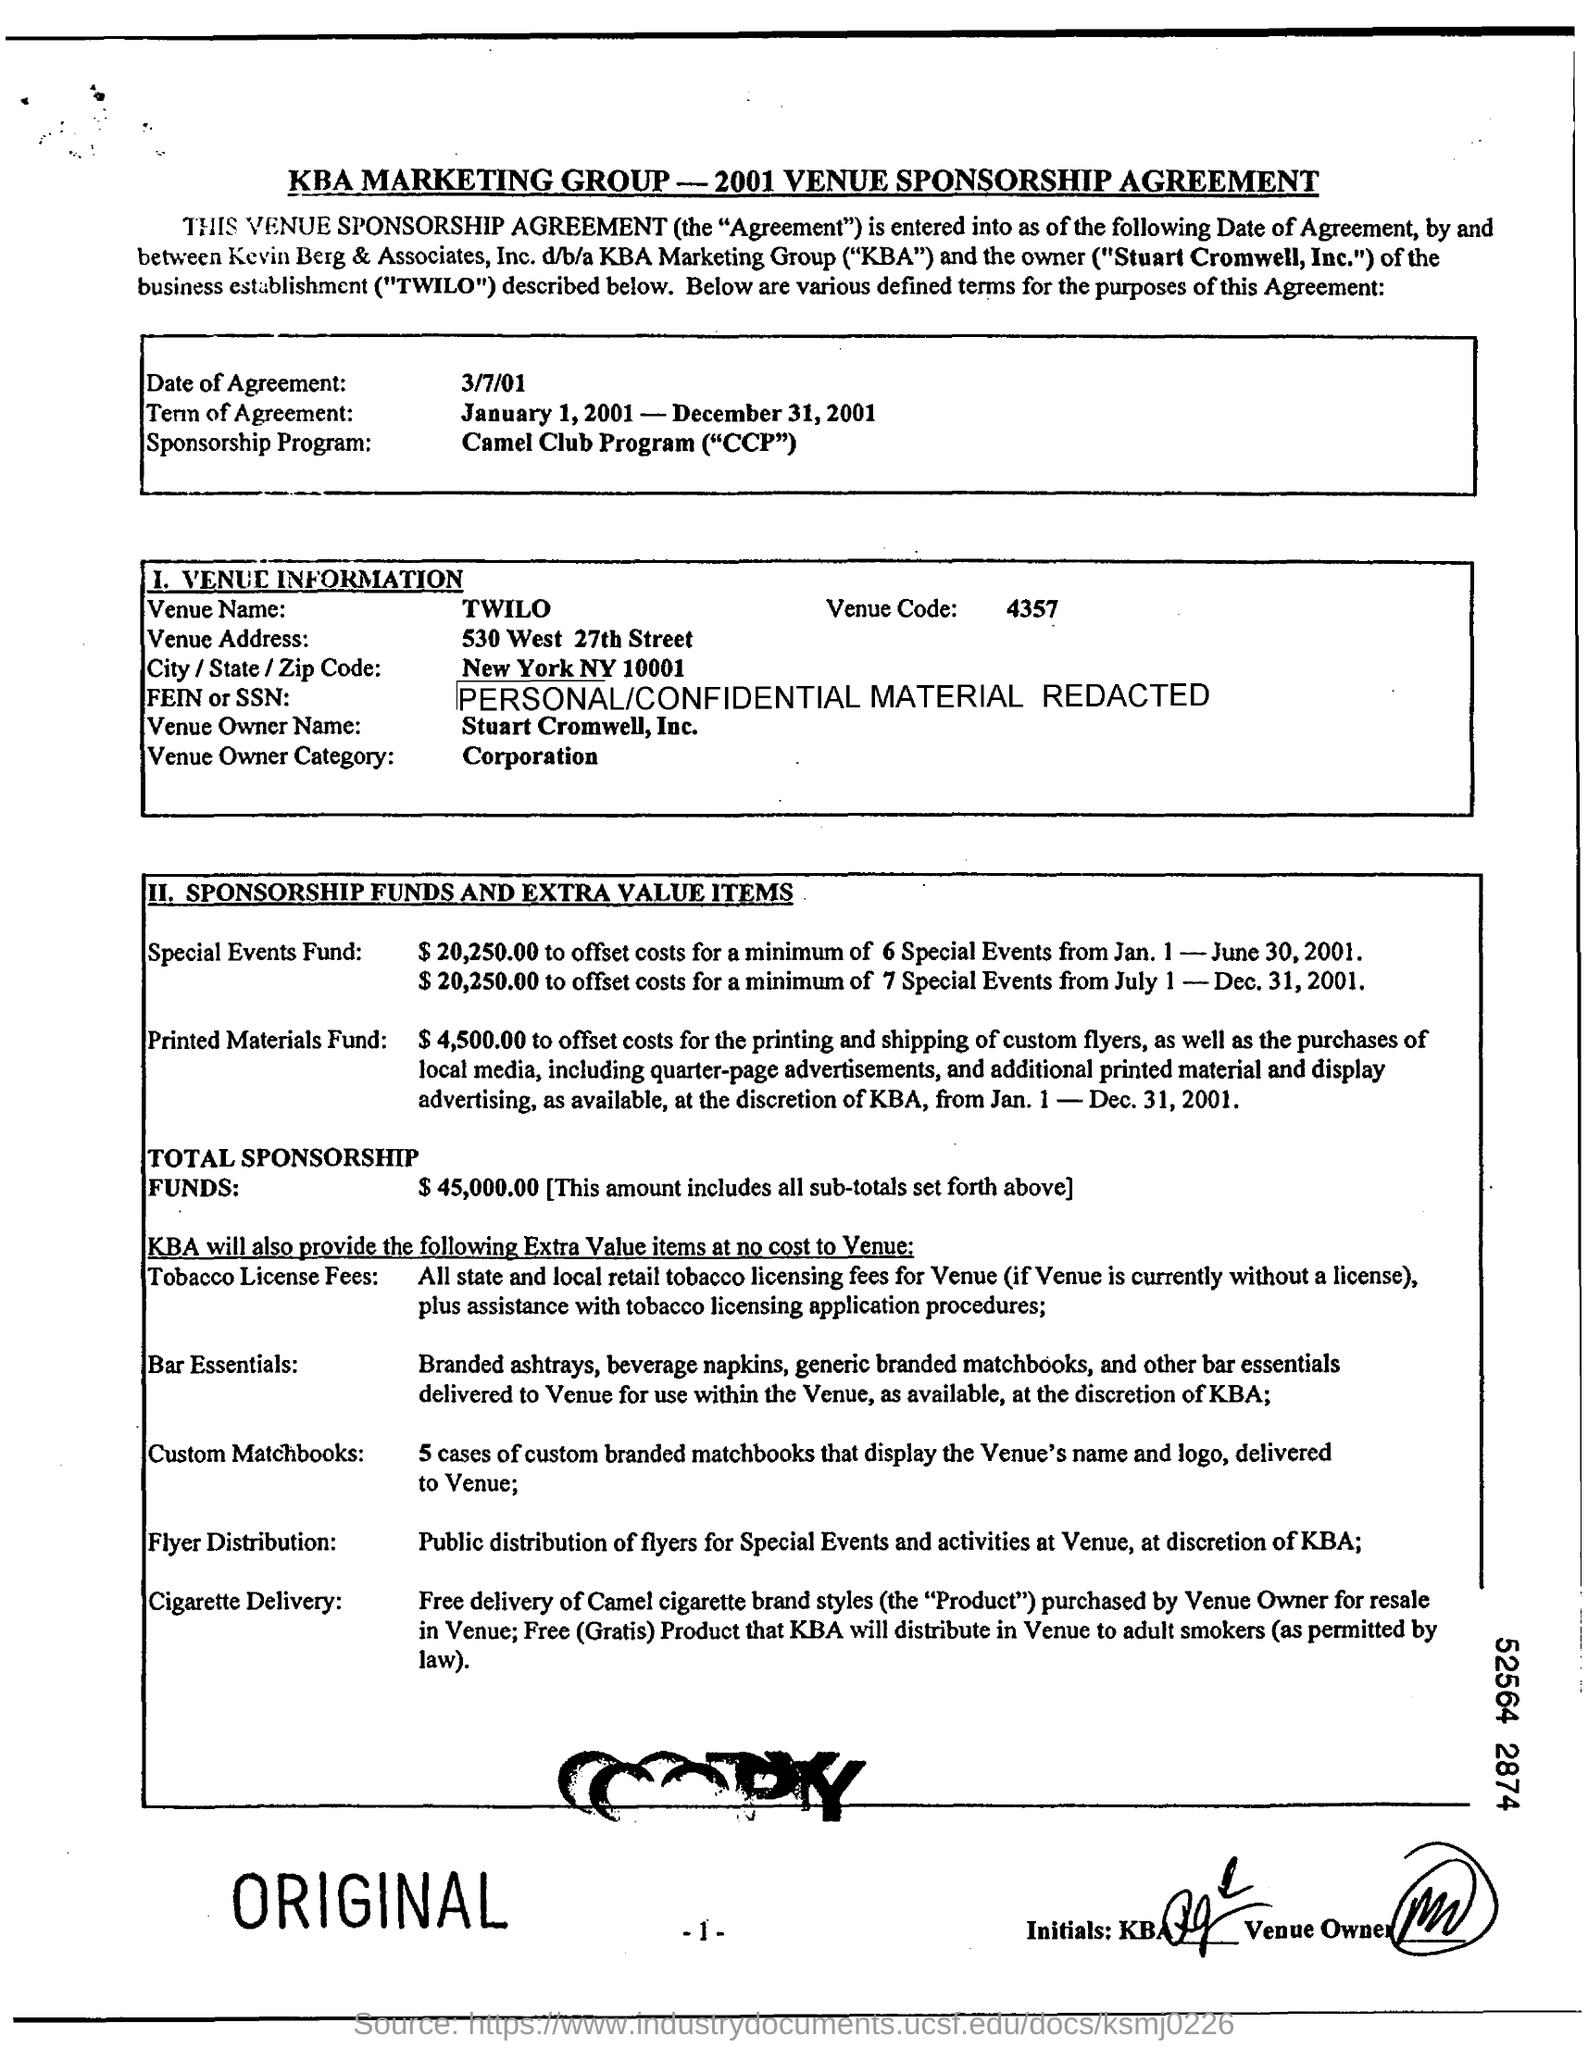What kind of entity is the owner of the venue classified as? The owner of TWILO is classified as a corporation according to the document. 